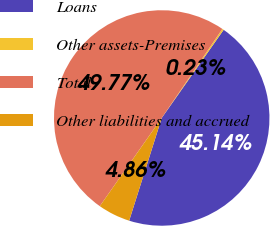<chart> <loc_0><loc_0><loc_500><loc_500><pie_chart><fcel>Loans<fcel>Other assets-Premises<fcel>Total<fcel>Other liabilities and accrued<nl><fcel>45.14%<fcel>0.23%<fcel>49.77%<fcel>4.86%<nl></chart> 